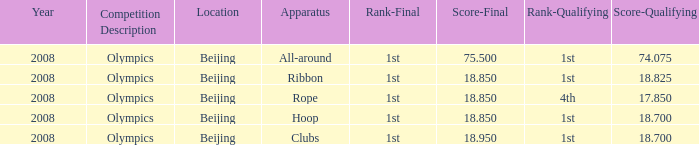What was her concluding score for the ribbon apparatus? 18.85. 